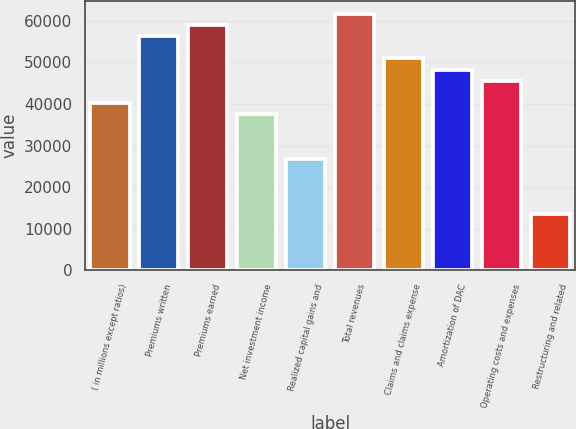Convert chart. <chart><loc_0><loc_0><loc_500><loc_500><bar_chart><fcel>( in millions except ratios)<fcel>Premiums written<fcel>Premiums earned<fcel>Net investment income<fcel>Realized capital gains and<fcel>Total revenues<fcel>Claims and claims expense<fcel>Amortization of DAC<fcel>Operating costs and expenses<fcel>Restructuring and related<nl><fcel>40237.4<fcel>56332.4<fcel>59014.9<fcel>37555<fcel>26825<fcel>61697.4<fcel>50967.4<fcel>48284.9<fcel>45602.4<fcel>13412.5<nl></chart> 